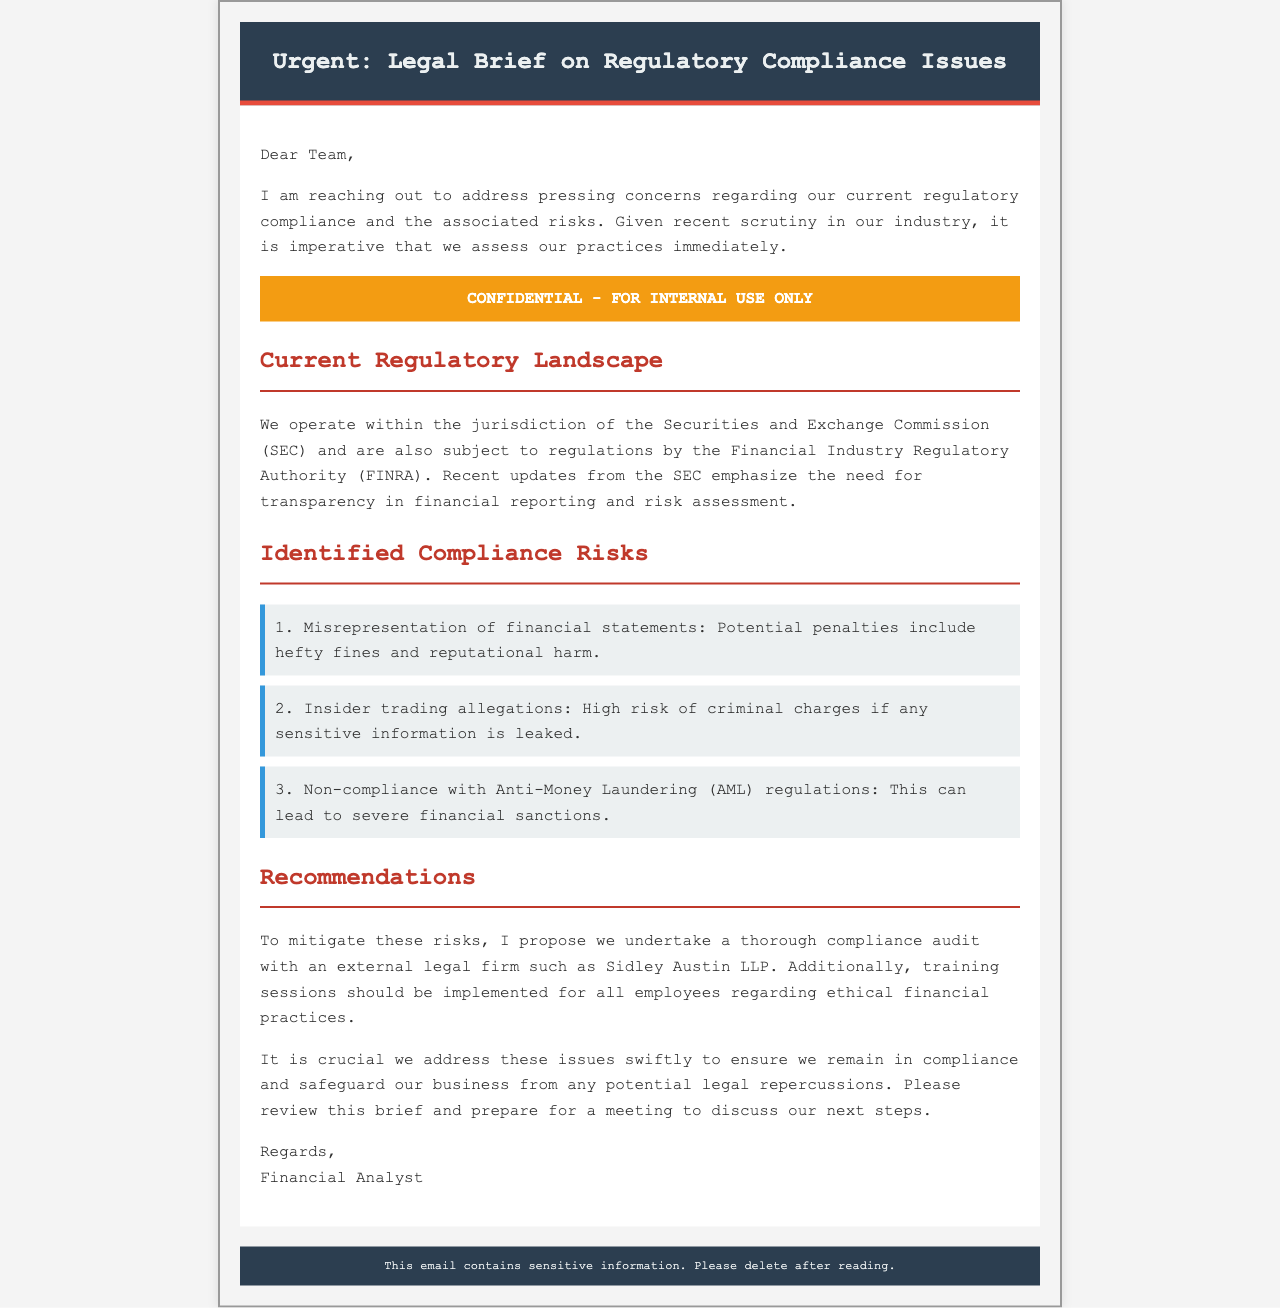What is the main subject of the email? The main subject is about issues related to regulatory compliance, highlighting risks and recommended actions.
Answer: Regulatory Compliance Issues Who is the email addressed to? The email is addressed to the "Team," indicating it is meant for internal stakeholders.
Answer: Team Which commission's regulations are highlighted? The email mentions the Securities and Exchange Commission, which governs financial practices in the industry.
Answer: Securities and Exchange Commission What are the penalties for misrepresentation of financial statements? The document states that potential penalties include hefty fines and reputational harm associated with misrepresentation.
Answer: Hefty fines and reputational harm Which external firm is recommended for the compliance audit? The email suggests undertaking a compliance audit with Sidley Austin LLP to manage regulatory risks effectively.
Answer: Sidley Austin LLP What is one of the identified compliance risks mentioned? The email outlines various compliance risks, one of which is misrepresentation of financial statements.
Answer: Misrepresentation of financial statements What should be implemented for training according to the recommendations? The recommendations include implementing training sessions for employees on ethical financial practices.
Answer: Training sessions Why is this email labeled as confidential? The email is marked confidential signifying the sensitive nature of the information contained within, which should be internal only.
Answer: Sensitive information What is a potential consequence of non-compliance with AML regulations? The document notes that non-compliance with Anti-Money Laundering regulations can lead to severe financial sanctions.
Answer: Severe financial sanctions 